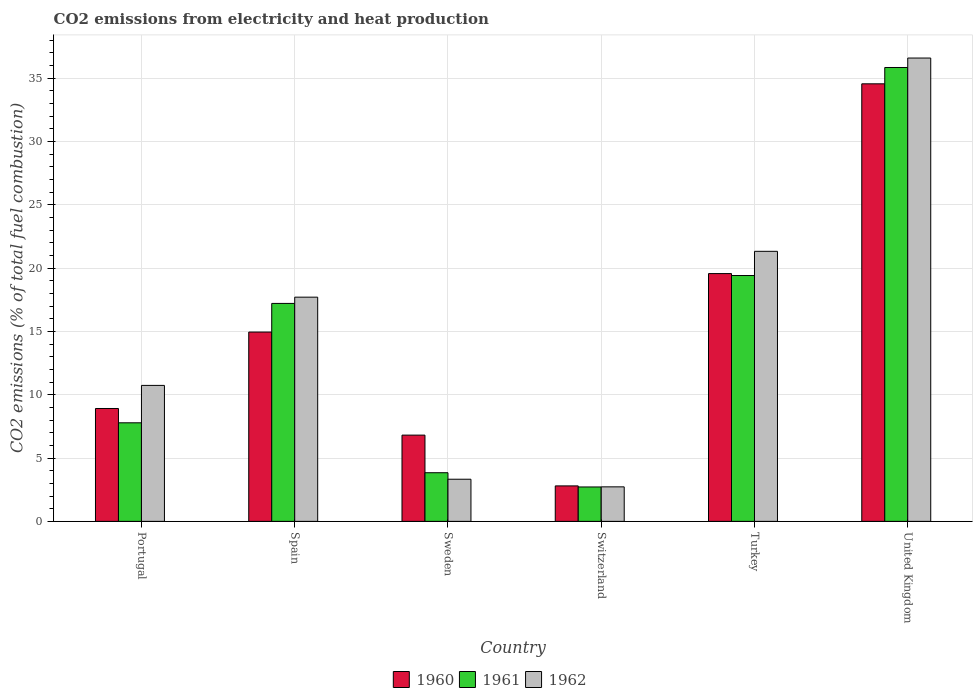How many groups of bars are there?
Provide a succinct answer. 6. How many bars are there on the 6th tick from the left?
Offer a terse response. 3. How many bars are there on the 6th tick from the right?
Ensure brevity in your answer.  3. What is the label of the 5th group of bars from the left?
Offer a terse response. Turkey. In how many cases, is the number of bars for a given country not equal to the number of legend labels?
Make the answer very short. 0. What is the amount of CO2 emitted in 1960 in Switzerland?
Provide a short and direct response. 2.8. Across all countries, what is the maximum amount of CO2 emitted in 1962?
Your answer should be compact. 36.58. Across all countries, what is the minimum amount of CO2 emitted in 1960?
Give a very brief answer. 2.8. In which country was the amount of CO2 emitted in 1960 maximum?
Offer a very short reply. United Kingdom. In which country was the amount of CO2 emitted in 1962 minimum?
Offer a very short reply. Switzerland. What is the total amount of CO2 emitted in 1960 in the graph?
Offer a terse response. 87.57. What is the difference between the amount of CO2 emitted in 1961 in Portugal and that in Spain?
Ensure brevity in your answer.  -9.43. What is the difference between the amount of CO2 emitted in 1961 in Sweden and the amount of CO2 emitted in 1962 in Switzerland?
Provide a succinct answer. 1.12. What is the average amount of CO2 emitted in 1960 per country?
Your response must be concise. 14.6. What is the difference between the amount of CO2 emitted of/in 1961 and amount of CO2 emitted of/in 1960 in United Kingdom?
Your answer should be compact. 1.29. What is the ratio of the amount of CO2 emitted in 1962 in Portugal to that in Turkey?
Offer a terse response. 0.5. Is the amount of CO2 emitted in 1961 in Spain less than that in United Kingdom?
Give a very brief answer. Yes. What is the difference between the highest and the second highest amount of CO2 emitted in 1962?
Ensure brevity in your answer.  -18.88. What is the difference between the highest and the lowest amount of CO2 emitted in 1961?
Your answer should be very brief. 33.12. Is the sum of the amount of CO2 emitted in 1961 in Sweden and Turkey greater than the maximum amount of CO2 emitted in 1960 across all countries?
Ensure brevity in your answer.  No. How many countries are there in the graph?
Keep it short and to the point. 6. Does the graph contain any zero values?
Offer a very short reply. No. Does the graph contain grids?
Ensure brevity in your answer.  Yes. Where does the legend appear in the graph?
Give a very brief answer. Bottom center. What is the title of the graph?
Your answer should be compact. CO2 emissions from electricity and heat production. What is the label or title of the X-axis?
Offer a very short reply. Country. What is the label or title of the Y-axis?
Offer a very short reply. CO2 emissions (% of total fuel combustion). What is the CO2 emissions (% of total fuel combustion) in 1960 in Portugal?
Provide a short and direct response. 8.91. What is the CO2 emissions (% of total fuel combustion) in 1961 in Portugal?
Keep it short and to the point. 7.78. What is the CO2 emissions (% of total fuel combustion) in 1962 in Portugal?
Provide a short and direct response. 10.73. What is the CO2 emissions (% of total fuel combustion) of 1960 in Spain?
Provide a succinct answer. 14.95. What is the CO2 emissions (% of total fuel combustion) in 1961 in Spain?
Ensure brevity in your answer.  17.21. What is the CO2 emissions (% of total fuel combustion) in 1962 in Spain?
Give a very brief answer. 17.7. What is the CO2 emissions (% of total fuel combustion) in 1960 in Sweden?
Keep it short and to the point. 6.81. What is the CO2 emissions (% of total fuel combustion) in 1961 in Sweden?
Offer a very short reply. 3.84. What is the CO2 emissions (% of total fuel combustion) in 1962 in Sweden?
Offer a very short reply. 3.33. What is the CO2 emissions (% of total fuel combustion) in 1960 in Switzerland?
Ensure brevity in your answer.  2.8. What is the CO2 emissions (% of total fuel combustion) of 1961 in Switzerland?
Make the answer very short. 2.72. What is the CO2 emissions (% of total fuel combustion) of 1962 in Switzerland?
Provide a succinct answer. 2.72. What is the CO2 emissions (% of total fuel combustion) in 1960 in Turkey?
Make the answer very short. 19.56. What is the CO2 emissions (% of total fuel combustion) in 1961 in Turkey?
Offer a terse response. 19.41. What is the CO2 emissions (% of total fuel combustion) in 1962 in Turkey?
Offer a very short reply. 21.32. What is the CO2 emissions (% of total fuel combustion) in 1960 in United Kingdom?
Provide a short and direct response. 34.54. What is the CO2 emissions (% of total fuel combustion) of 1961 in United Kingdom?
Your response must be concise. 35.83. What is the CO2 emissions (% of total fuel combustion) of 1962 in United Kingdom?
Your response must be concise. 36.58. Across all countries, what is the maximum CO2 emissions (% of total fuel combustion) of 1960?
Give a very brief answer. 34.54. Across all countries, what is the maximum CO2 emissions (% of total fuel combustion) of 1961?
Give a very brief answer. 35.83. Across all countries, what is the maximum CO2 emissions (% of total fuel combustion) in 1962?
Give a very brief answer. 36.58. Across all countries, what is the minimum CO2 emissions (% of total fuel combustion) in 1960?
Offer a terse response. 2.8. Across all countries, what is the minimum CO2 emissions (% of total fuel combustion) in 1961?
Offer a very short reply. 2.72. Across all countries, what is the minimum CO2 emissions (% of total fuel combustion) in 1962?
Offer a very short reply. 2.72. What is the total CO2 emissions (% of total fuel combustion) in 1960 in the graph?
Make the answer very short. 87.57. What is the total CO2 emissions (% of total fuel combustion) in 1961 in the graph?
Offer a very short reply. 86.79. What is the total CO2 emissions (% of total fuel combustion) in 1962 in the graph?
Your response must be concise. 92.39. What is the difference between the CO2 emissions (% of total fuel combustion) in 1960 in Portugal and that in Spain?
Keep it short and to the point. -6.04. What is the difference between the CO2 emissions (% of total fuel combustion) in 1961 in Portugal and that in Spain?
Provide a short and direct response. -9.43. What is the difference between the CO2 emissions (% of total fuel combustion) of 1962 in Portugal and that in Spain?
Offer a terse response. -6.97. What is the difference between the CO2 emissions (% of total fuel combustion) of 1960 in Portugal and that in Sweden?
Provide a short and direct response. 2.1. What is the difference between the CO2 emissions (% of total fuel combustion) of 1961 in Portugal and that in Sweden?
Give a very brief answer. 3.94. What is the difference between the CO2 emissions (% of total fuel combustion) in 1962 in Portugal and that in Sweden?
Your response must be concise. 7.41. What is the difference between the CO2 emissions (% of total fuel combustion) in 1960 in Portugal and that in Switzerland?
Make the answer very short. 6.11. What is the difference between the CO2 emissions (% of total fuel combustion) in 1961 in Portugal and that in Switzerland?
Give a very brief answer. 5.07. What is the difference between the CO2 emissions (% of total fuel combustion) of 1962 in Portugal and that in Switzerland?
Your answer should be very brief. 8.01. What is the difference between the CO2 emissions (% of total fuel combustion) in 1960 in Portugal and that in Turkey?
Your answer should be very brief. -10.65. What is the difference between the CO2 emissions (% of total fuel combustion) of 1961 in Portugal and that in Turkey?
Your answer should be very brief. -11.63. What is the difference between the CO2 emissions (% of total fuel combustion) in 1962 in Portugal and that in Turkey?
Provide a succinct answer. -10.59. What is the difference between the CO2 emissions (% of total fuel combustion) in 1960 in Portugal and that in United Kingdom?
Provide a short and direct response. -25.63. What is the difference between the CO2 emissions (% of total fuel combustion) in 1961 in Portugal and that in United Kingdom?
Offer a terse response. -28.05. What is the difference between the CO2 emissions (% of total fuel combustion) in 1962 in Portugal and that in United Kingdom?
Make the answer very short. -25.84. What is the difference between the CO2 emissions (% of total fuel combustion) of 1960 in Spain and that in Sweden?
Offer a very short reply. 8.14. What is the difference between the CO2 emissions (% of total fuel combustion) in 1961 in Spain and that in Sweden?
Ensure brevity in your answer.  13.37. What is the difference between the CO2 emissions (% of total fuel combustion) of 1962 in Spain and that in Sweden?
Your answer should be compact. 14.37. What is the difference between the CO2 emissions (% of total fuel combustion) in 1960 in Spain and that in Switzerland?
Your answer should be very brief. 12.15. What is the difference between the CO2 emissions (% of total fuel combustion) of 1961 in Spain and that in Switzerland?
Provide a succinct answer. 14.49. What is the difference between the CO2 emissions (% of total fuel combustion) in 1962 in Spain and that in Switzerland?
Offer a very short reply. 14.98. What is the difference between the CO2 emissions (% of total fuel combustion) of 1960 in Spain and that in Turkey?
Your answer should be very brief. -4.62. What is the difference between the CO2 emissions (% of total fuel combustion) of 1961 in Spain and that in Turkey?
Offer a terse response. -2.2. What is the difference between the CO2 emissions (% of total fuel combustion) of 1962 in Spain and that in Turkey?
Give a very brief answer. -3.62. What is the difference between the CO2 emissions (% of total fuel combustion) in 1960 in Spain and that in United Kingdom?
Your answer should be compact. -19.6. What is the difference between the CO2 emissions (% of total fuel combustion) in 1961 in Spain and that in United Kingdom?
Make the answer very short. -18.63. What is the difference between the CO2 emissions (% of total fuel combustion) of 1962 in Spain and that in United Kingdom?
Provide a short and direct response. -18.88. What is the difference between the CO2 emissions (% of total fuel combustion) of 1960 in Sweden and that in Switzerland?
Give a very brief answer. 4.01. What is the difference between the CO2 emissions (% of total fuel combustion) of 1961 in Sweden and that in Switzerland?
Make the answer very short. 1.12. What is the difference between the CO2 emissions (% of total fuel combustion) of 1962 in Sweden and that in Switzerland?
Your answer should be compact. 0.6. What is the difference between the CO2 emissions (% of total fuel combustion) in 1960 in Sweden and that in Turkey?
Offer a very short reply. -12.75. What is the difference between the CO2 emissions (% of total fuel combustion) of 1961 in Sweden and that in Turkey?
Provide a short and direct response. -15.57. What is the difference between the CO2 emissions (% of total fuel combustion) in 1962 in Sweden and that in Turkey?
Give a very brief answer. -17.99. What is the difference between the CO2 emissions (% of total fuel combustion) of 1960 in Sweden and that in United Kingdom?
Offer a terse response. -27.74. What is the difference between the CO2 emissions (% of total fuel combustion) of 1961 in Sweden and that in United Kingdom?
Provide a short and direct response. -31.99. What is the difference between the CO2 emissions (% of total fuel combustion) in 1962 in Sweden and that in United Kingdom?
Provide a succinct answer. -33.25. What is the difference between the CO2 emissions (% of total fuel combustion) in 1960 in Switzerland and that in Turkey?
Your response must be concise. -16.76. What is the difference between the CO2 emissions (% of total fuel combustion) in 1961 in Switzerland and that in Turkey?
Make the answer very short. -16.69. What is the difference between the CO2 emissions (% of total fuel combustion) of 1962 in Switzerland and that in Turkey?
Your response must be concise. -18.59. What is the difference between the CO2 emissions (% of total fuel combustion) of 1960 in Switzerland and that in United Kingdom?
Offer a terse response. -31.74. What is the difference between the CO2 emissions (% of total fuel combustion) of 1961 in Switzerland and that in United Kingdom?
Offer a very short reply. -33.12. What is the difference between the CO2 emissions (% of total fuel combustion) in 1962 in Switzerland and that in United Kingdom?
Offer a very short reply. -33.85. What is the difference between the CO2 emissions (% of total fuel combustion) in 1960 in Turkey and that in United Kingdom?
Offer a very short reply. -14.98. What is the difference between the CO2 emissions (% of total fuel combustion) of 1961 in Turkey and that in United Kingdom?
Offer a terse response. -16.42. What is the difference between the CO2 emissions (% of total fuel combustion) in 1962 in Turkey and that in United Kingdom?
Make the answer very short. -15.26. What is the difference between the CO2 emissions (% of total fuel combustion) of 1960 in Portugal and the CO2 emissions (% of total fuel combustion) of 1961 in Spain?
Your answer should be very brief. -8.3. What is the difference between the CO2 emissions (% of total fuel combustion) in 1960 in Portugal and the CO2 emissions (% of total fuel combustion) in 1962 in Spain?
Offer a very short reply. -8.79. What is the difference between the CO2 emissions (% of total fuel combustion) in 1961 in Portugal and the CO2 emissions (% of total fuel combustion) in 1962 in Spain?
Your answer should be very brief. -9.92. What is the difference between the CO2 emissions (% of total fuel combustion) of 1960 in Portugal and the CO2 emissions (% of total fuel combustion) of 1961 in Sweden?
Give a very brief answer. 5.07. What is the difference between the CO2 emissions (% of total fuel combustion) in 1960 in Portugal and the CO2 emissions (% of total fuel combustion) in 1962 in Sweden?
Make the answer very short. 5.58. What is the difference between the CO2 emissions (% of total fuel combustion) in 1961 in Portugal and the CO2 emissions (% of total fuel combustion) in 1962 in Sweden?
Offer a terse response. 4.45. What is the difference between the CO2 emissions (% of total fuel combustion) of 1960 in Portugal and the CO2 emissions (% of total fuel combustion) of 1961 in Switzerland?
Ensure brevity in your answer.  6.2. What is the difference between the CO2 emissions (% of total fuel combustion) of 1960 in Portugal and the CO2 emissions (% of total fuel combustion) of 1962 in Switzerland?
Provide a short and direct response. 6.19. What is the difference between the CO2 emissions (% of total fuel combustion) of 1961 in Portugal and the CO2 emissions (% of total fuel combustion) of 1962 in Switzerland?
Ensure brevity in your answer.  5.06. What is the difference between the CO2 emissions (% of total fuel combustion) of 1960 in Portugal and the CO2 emissions (% of total fuel combustion) of 1961 in Turkey?
Give a very brief answer. -10.5. What is the difference between the CO2 emissions (% of total fuel combustion) of 1960 in Portugal and the CO2 emissions (% of total fuel combustion) of 1962 in Turkey?
Provide a short and direct response. -12.41. What is the difference between the CO2 emissions (% of total fuel combustion) of 1961 in Portugal and the CO2 emissions (% of total fuel combustion) of 1962 in Turkey?
Your response must be concise. -13.54. What is the difference between the CO2 emissions (% of total fuel combustion) in 1960 in Portugal and the CO2 emissions (% of total fuel combustion) in 1961 in United Kingdom?
Keep it short and to the point. -26.92. What is the difference between the CO2 emissions (% of total fuel combustion) of 1960 in Portugal and the CO2 emissions (% of total fuel combustion) of 1962 in United Kingdom?
Provide a succinct answer. -27.67. What is the difference between the CO2 emissions (% of total fuel combustion) in 1961 in Portugal and the CO2 emissions (% of total fuel combustion) in 1962 in United Kingdom?
Offer a terse response. -28.8. What is the difference between the CO2 emissions (% of total fuel combustion) of 1960 in Spain and the CO2 emissions (% of total fuel combustion) of 1961 in Sweden?
Your answer should be compact. 11.11. What is the difference between the CO2 emissions (% of total fuel combustion) of 1960 in Spain and the CO2 emissions (% of total fuel combustion) of 1962 in Sweden?
Offer a terse response. 11.62. What is the difference between the CO2 emissions (% of total fuel combustion) in 1961 in Spain and the CO2 emissions (% of total fuel combustion) in 1962 in Sweden?
Offer a very short reply. 13.88. What is the difference between the CO2 emissions (% of total fuel combustion) of 1960 in Spain and the CO2 emissions (% of total fuel combustion) of 1961 in Switzerland?
Ensure brevity in your answer.  12.23. What is the difference between the CO2 emissions (% of total fuel combustion) in 1960 in Spain and the CO2 emissions (% of total fuel combustion) in 1962 in Switzerland?
Give a very brief answer. 12.22. What is the difference between the CO2 emissions (% of total fuel combustion) of 1961 in Spain and the CO2 emissions (% of total fuel combustion) of 1962 in Switzerland?
Keep it short and to the point. 14.48. What is the difference between the CO2 emissions (% of total fuel combustion) in 1960 in Spain and the CO2 emissions (% of total fuel combustion) in 1961 in Turkey?
Give a very brief answer. -4.46. What is the difference between the CO2 emissions (% of total fuel combustion) in 1960 in Spain and the CO2 emissions (% of total fuel combustion) in 1962 in Turkey?
Your response must be concise. -6.37. What is the difference between the CO2 emissions (% of total fuel combustion) of 1961 in Spain and the CO2 emissions (% of total fuel combustion) of 1962 in Turkey?
Your answer should be compact. -4.11. What is the difference between the CO2 emissions (% of total fuel combustion) in 1960 in Spain and the CO2 emissions (% of total fuel combustion) in 1961 in United Kingdom?
Make the answer very short. -20.89. What is the difference between the CO2 emissions (% of total fuel combustion) of 1960 in Spain and the CO2 emissions (% of total fuel combustion) of 1962 in United Kingdom?
Give a very brief answer. -21.63. What is the difference between the CO2 emissions (% of total fuel combustion) in 1961 in Spain and the CO2 emissions (% of total fuel combustion) in 1962 in United Kingdom?
Your answer should be very brief. -19.37. What is the difference between the CO2 emissions (% of total fuel combustion) of 1960 in Sweden and the CO2 emissions (% of total fuel combustion) of 1961 in Switzerland?
Give a very brief answer. 4.09. What is the difference between the CO2 emissions (% of total fuel combustion) of 1960 in Sweden and the CO2 emissions (% of total fuel combustion) of 1962 in Switzerland?
Keep it short and to the point. 4.08. What is the difference between the CO2 emissions (% of total fuel combustion) of 1961 in Sweden and the CO2 emissions (% of total fuel combustion) of 1962 in Switzerland?
Give a very brief answer. 1.12. What is the difference between the CO2 emissions (% of total fuel combustion) of 1960 in Sweden and the CO2 emissions (% of total fuel combustion) of 1961 in Turkey?
Your answer should be compact. -12.6. What is the difference between the CO2 emissions (% of total fuel combustion) in 1960 in Sweden and the CO2 emissions (% of total fuel combustion) in 1962 in Turkey?
Provide a short and direct response. -14.51. What is the difference between the CO2 emissions (% of total fuel combustion) of 1961 in Sweden and the CO2 emissions (% of total fuel combustion) of 1962 in Turkey?
Your answer should be compact. -17.48. What is the difference between the CO2 emissions (% of total fuel combustion) in 1960 in Sweden and the CO2 emissions (% of total fuel combustion) in 1961 in United Kingdom?
Provide a succinct answer. -29.02. What is the difference between the CO2 emissions (% of total fuel combustion) of 1960 in Sweden and the CO2 emissions (% of total fuel combustion) of 1962 in United Kingdom?
Offer a very short reply. -29.77. What is the difference between the CO2 emissions (% of total fuel combustion) in 1961 in Sweden and the CO2 emissions (% of total fuel combustion) in 1962 in United Kingdom?
Offer a very short reply. -32.74. What is the difference between the CO2 emissions (% of total fuel combustion) in 1960 in Switzerland and the CO2 emissions (% of total fuel combustion) in 1961 in Turkey?
Your answer should be compact. -16.61. What is the difference between the CO2 emissions (% of total fuel combustion) of 1960 in Switzerland and the CO2 emissions (% of total fuel combustion) of 1962 in Turkey?
Provide a short and direct response. -18.52. What is the difference between the CO2 emissions (% of total fuel combustion) of 1961 in Switzerland and the CO2 emissions (% of total fuel combustion) of 1962 in Turkey?
Your answer should be compact. -18.6. What is the difference between the CO2 emissions (% of total fuel combustion) of 1960 in Switzerland and the CO2 emissions (% of total fuel combustion) of 1961 in United Kingdom?
Your answer should be very brief. -33.03. What is the difference between the CO2 emissions (% of total fuel combustion) of 1960 in Switzerland and the CO2 emissions (% of total fuel combustion) of 1962 in United Kingdom?
Ensure brevity in your answer.  -33.78. What is the difference between the CO2 emissions (% of total fuel combustion) in 1961 in Switzerland and the CO2 emissions (% of total fuel combustion) in 1962 in United Kingdom?
Provide a short and direct response. -33.86. What is the difference between the CO2 emissions (% of total fuel combustion) of 1960 in Turkey and the CO2 emissions (% of total fuel combustion) of 1961 in United Kingdom?
Give a very brief answer. -16.27. What is the difference between the CO2 emissions (% of total fuel combustion) in 1960 in Turkey and the CO2 emissions (% of total fuel combustion) in 1962 in United Kingdom?
Offer a very short reply. -17.02. What is the difference between the CO2 emissions (% of total fuel combustion) of 1961 in Turkey and the CO2 emissions (% of total fuel combustion) of 1962 in United Kingdom?
Offer a terse response. -17.17. What is the average CO2 emissions (% of total fuel combustion) in 1960 per country?
Provide a succinct answer. 14.6. What is the average CO2 emissions (% of total fuel combustion) of 1961 per country?
Ensure brevity in your answer.  14.46. What is the average CO2 emissions (% of total fuel combustion) of 1962 per country?
Ensure brevity in your answer.  15.4. What is the difference between the CO2 emissions (% of total fuel combustion) in 1960 and CO2 emissions (% of total fuel combustion) in 1961 in Portugal?
Give a very brief answer. 1.13. What is the difference between the CO2 emissions (% of total fuel combustion) in 1960 and CO2 emissions (% of total fuel combustion) in 1962 in Portugal?
Offer a terse response. -1.82. What is the difference between the CO2 emissions (% of total fuel combustion) of 1961 and CO2 emissions (% of total fuel combustion) of 1962 in Portugal?
Make the answer very short. -2.95. What is the difference between the CO2 emissions (% of total fuel combustion) in 1960 and CO2 emissions (% of total fuel combustion) in 1961 in Spain?
Your answer should be compact. -2.26. What is the difference between the CO2 emissions (% of total fuel combustion) in 1960 and CO2 emissions (% of total fuel combustion) in 1962 in Spain?
Offer a very short reply. -2.75. What is the difference between the CO2 emissions (% of total fuel combustion) of 1961 and CO2 emissions (% of total fuel combustion) of 1962 in Spain?
Offer a terse response. -0.49. What is the difference between the CO2 emissions (% of total fuel combustion) of 1960 and CO2 emissions (% of total fuel combustion) of 1961 in Sweden?
Your response must be concise. 2.97. What is the difference between the CO2 emissions (% of total fuel combustion) of 1960 and CO2 emissions (% of total fuel combustion) of 1962 in Sweden?
Ensure brevity in your answer.  3.48. What is the difference between the CO2 emissions (% of total fuel combustion) of 1961 and CO2 emissions (% of total fuel combustion) of 1962 in Sweden?
Keep it short and to the point. 0.51. What is the difference between the CO2 emissions (% of total fuel combustion) in 1960 and CO2 emissions (% of total fuel combustion) in 1961 in Switzerland?
Your answer should be compact. 0.08. What is the difference between the CO2 emissions (% of total fuel combustion) of 1960 and CO2 emissions (% of total fuel combustion) of 1962 in Switzerland?
Make the answer very short. 0.07. What is the difference between the CO2 emissions (% of total fuel combustion) of 1961 and CO2 emissions (% of total fuel combustion) of 1962 in Switzerland?
Offer a terse response. -0.01. What is the difference between the CO2 emissions (% of total fuel combustion) in 1960 and CO2 emissions (% of total fuel combustion) in 1961 in Turkey?
Ensure brevity in your answer.  0.15. What is the difference between the CO2 emissions (% of total fuel combustion) in 1960 and CO2 emissions (% of total fuel combustion) in 1962 in Turkey?
Keep it short and to the point. -1.76. What is the difference between the CO2 emissions (% of total fuel combustion) of 1961 and CO2 emissions (% of total fuel combustion) of 1962 in Turkey?
Your response must be concise. -1.91. What is the difference between the CO2 emissions (% of total fuel combustion) of 1960 and CO2 emissions (% of total fuel combustion) of 1961 in United Kingdom?
Give a very brief answer. -1.29. What is the difference between the CO2 emissions (% of total fuel combustion) of 1960 and CO2 emissions (% of total fuel combustion) of 1962 in United Kingdom?
Your answer should be very brief. -2.03. What is the difference between the CO2 emissions (% of total fuel combustion) of 1961 and CO2 emissions (% of total fuel combustion) of 1962 in United Kingdom?
Keep it short and to the point. -0.75. What is the ratio of the CO2 emissions (% of total fuel combustion) in 1960 in Portugal to that in Spain?
Ensure brevity in your answer.  0.6. What is the ratio of the CO2 emissions (% of total fuel combustion) of 1961 in Portugal to that in Spain?
Offer a terse response. 0.45. What is the ratio of the CO2 emissions (% of total fuel combustion) of 1962 in Portugal to that in Spain?
Provide a succinct answer. 0.61. What is the ratio of the CO2 emissions (% of total fuel combustion) in 1960 in Portugal to that in Sweden?
Keep it short and to the point. 1.31. What is the ratio of the CO2 emissions (% of total fuel combustion) in 1961 in Portugal to that in Sweden?
Offer a very short reply. 2.03. What is the ratio of the CO2 emissions (% of total fuel combustion) of 1962 in Portugal to that in Sweden?
Provide a short and direct response. 3.23. What is the ratio of the CO2 emissions (% of total fuel combustion) in 1960 in Portugal to that in Switzerland?
Make the answer very short. 3.18. What is the ratio of the CO2 emissions (% of total fuel combustion) in 1961 in Portugal to that in Switzerland?
Your answer should be very brief. 2.87. What is the ratio of the CO2 emissions (% of total fuel combustion) in 1962 in Portugal to that in Switzerland?
Offer a very short reply. 3.94. What is the ratio of the CO2 emissions (% of total fuel combustion) in 1960 in Portugal to that in Turkey?
Provide a succinct answer. 0.46. What is the ratio of the CO2 emissions (% of total fuel combustion) of 1961 in Portugal to that in Turkey?
Your answer should be very brief. 0.4. What is the ratio of the CO2 emissions (% of total fuel combustion) of 1962 in Portugal to that in Turkey?
Ensure brevity in your answer.  0.5. What is the ratio of the CO2 emissions (% of total fuel combustion) in 1960 in Portugal to that in United Kingdom?
Your answer should be compact. 0.26. What is the ratio of the CO2 emissions (% of total fuel combustion) of 1961 in Portugal to that in United Kingdom?
Offer a very short reply. 0.22. What is the ratio of the CO2 emissions (% of total fuel combustion) of 1962 in Portugal to that in United Kingdom?
Provide a succinct answer. 0.29. What is the ratio of the CO2 emissions (% of total fuel combustion) of 1960 in Spain to that in Sweden?
Offer a very short reply. 2.2. What is the ratio of the CO2 emissions (% of total fuel combustion) in 1961 in Spain to that in Sweden?
Your answer should be compact. 4.48. What is the ratio of the CO2 emissions (% of total fuel combustion) of 1962 in Spain to that in Sweden?
Your answer should be very brief. 5.32. What is the ratio of the CO2 emissions (% of total fuel combustion) in 1960 in Spain to that in Switzerland?
Keep it short and to the point. 5.34. What is the ratio of the CO2 emissions (% of total fuel combustion) of 1961 in Spain to that in Switzerland?
Offer a terse response. 6.34. What is the ratio of the CO2 emissions (% of total fuel combustion) of 1962 in Spain to that in Switzerland?
Your answer should be compact. 6.5. What is the ratio of the CO2 emissions (% of total fuel combustion) in 1960 in Spain to that in Turkey?
Ensure brevity in your answer.  0.76. What is the ratio of the CO2 emissions (% of total fuel combustion) in 1961 in Spain to that in Turkey?
Give a very brief answer. 0.89. What is the ratio of the CO2 emissions (% of total fuel combustion) of 1962 in Spain to that in Turkey?
Keep it short and to the point. 0.83. What is the ratio of the CO2 emissions (% of total fuel combustion) of 1960 in Spain to that in United Kingdom?
Your response must be concise. 0.43. What is the ratio of the CO2 emissions (% of total fuel combustion) of 1961 in Spain to that in United Kingdom?
Keep it short and to the point. 0.48. What is the ratio of the CO2 emissions (% of total fuel combustion) of 1962 in Spain to that in United Kingdom?
Keep it short and to the point. 0.48. What is the ratio of the CO2 emissions (% of total fuel combustion) in 1960 in Sweden to that in Switzerland?
Your response must be concise. 2.43. What is the ratio of the CO2 emissions (% of total fuel combustion) in 1961 in Sweden to that in Switzerland?
Your answer should be very brief. 1.41. What is the ratio of the CO2 emissions (% of total fuel combustion) of 1962 in Sweden to that in Switzerland?
Keep it short and to the point. 1.22. What is the ratio of the CO2 emissions (% of total fuel combustion) of 1960 in Sweden to that in Turkey?
Provide a succinct answer. 0.35. What is the ratio of the CO2 emissions (% of total fuel combustion) in 1961 in Sweden to that in Turkey?
Offer a very short reply. 0.2. What is the ratio of the CO2 emissions (% of total fuel combustion) of 1962 in Sweden to that in Turkey?
Keep it short and to the point. 0.16. What is the ratio of the CO2 emissions (% of total fuel combustion) of 1960 in Sweden to that in United Kingdom?
Offer a terse response. 0.2. What is the ratio of the CO2 emissions (% of total fuel combustion) in 1961 in Sweden to that in United Kingdom?
Offer a very short reply. 0.11. What is the ratio of the CO2 emissions (% of total fuel combustion) in 1962 in Sweden to that in United Kingdom?
Your answer should be very brief. 0.09. What is the ratio of the CO2 emissions (% of total fuel combustion) in 1960 in Switzerland to that in Turkey?
Your response must be concise. 0.14. What is the ratio of the CO2 emissions (% of total fuel combustion) of 1961 in Switzerland to that in Turkey?
Provide a short and direct response. 0.14. What is the ratio of the CO2 emissions (% of total fuel combustion) of 1962 in Switzerland to that in Turkey?
Your response must be concise. 0.13. What is the ratio of the CO2 emissions (% of total fuel combustion) in 1960 in Switzerland to that in United Kingdom?
Offer a very short reply. 0.08. What is the ratio of the CO2 emissions (% of total fuel combustion) in 1961 in Switzerland to that in United Kingdom?
Your answer should be very brief. 0.08. What is the ratio of the CO2 emissions (% of total fuel combustion) in 1962 in Switzerland to that in United Kingdom?
Your answer should be very brief. 0.07. What is the ratio of the CO2 emissions (% of total fuel combustion) in 1960 in Turkey to that in United Kingdom?
Ensure brevity in your answer.  0.57. What is the ratio of the CO2 emissions (% of total fuel combustion) in 1961 in Turkey to that in United Kingdom?
Ensure brevity in your answer.  0.54. What is the ratio of the CO2 emissions (% of total fuel combustion) of 1962 in Turkey to that in United Kingdom?
Give a very brief answer. 0.58. What is the difference between the highest and the second highest CO2 emissions (% of total fuel combustion) of 1960?
Offer a very short reply. 14.98. What is the difference between the highest and the second highest CO2 emissions (% of total fuel combustion) in 1961?
Keep it short and to the point. 16.42. What is the difference between the highest and the second highest CO2 emissions (% of total fuel combustion) in 1962?
Provide a short and direct response. 15.26. What is the difference between the highest and the lowest CO2 emissions (% of total fuel combustion) in 1960?
Offer a very short reply. 31.74. What is the difference between the highest and the lowest CO2 emissions (% of total fuel combustion) of 1961?
Ensure brevity in your answer.  33.12. What is the difference between the highest and the lowest CO2 emissions (% of total fuel combustion) in 1962?
Give a very brief answer. 33.85. 